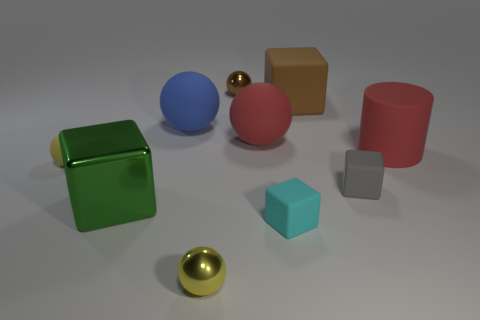What can you infer about the size of the objects relative to each other? While precise measurements cannot be determined from the image alone, we can infer relative sizes through comparison. The blue sphere, pink cylinder, and brown cube are similar in scale and are the largest objects present. The green cube is slightly smaller but of a comparable size. The smaller silver cube and the golden sphere are noticeably smaller, roughly half the diameter of the blue sphere and pink cylinder. 